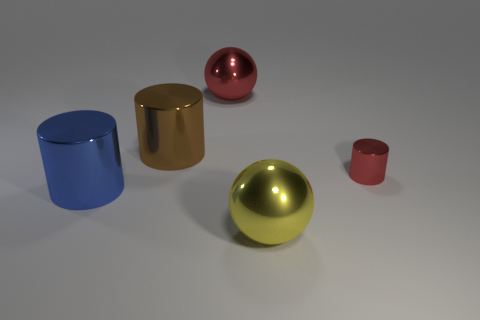Subtract all big blue cylinders. How many cylinders are left? 2 Subtract all cylinders. How many objects are left? 2 Subtract 1 cylinders. How many cylinders are left? 2 Subtract all red cylinders. Subtract all yellow cubes. How many cylinders are left? 2 Subtract all purple balls. How many green cylinders are left? 0 Subtract all brown objects. Subtract all small metallic cubes. How many objects are left? 4 Add 4 big red shiny balls. How many big red shiny balls are left? 5 Add 3 tiny red metallic objects. How many tiny red metallic objects exist? 4 Add 2 spheres. How many objects exist? 7 Subtract all red cylinders. How many cylinders are left? 2 